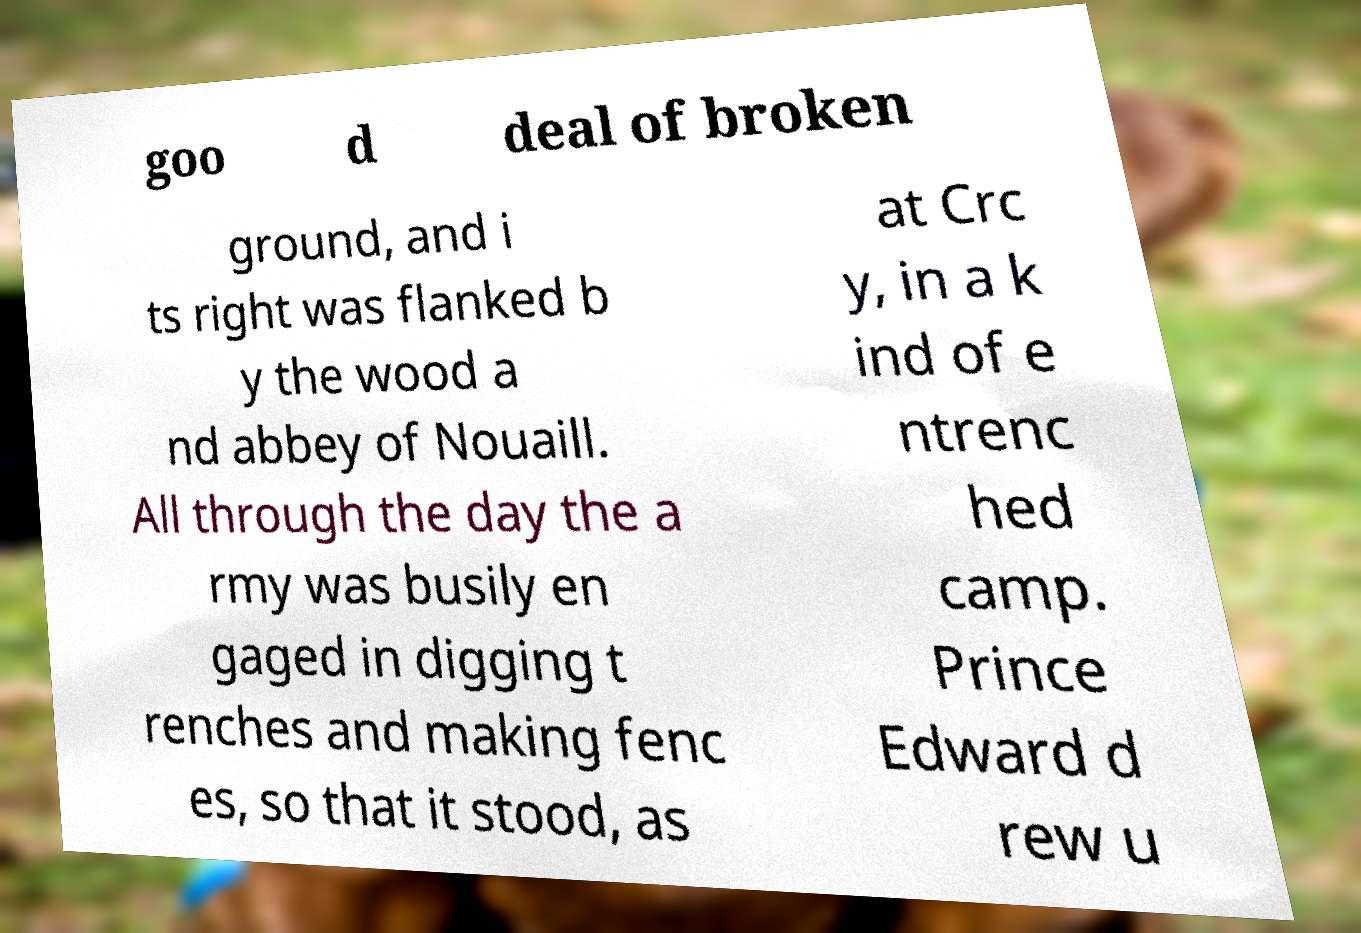Could you extract and type out the text from this image? goo d deal of broken ground, and i ts right was flanked b y the wood a nd abbey of Nouaill. All through the day the a rmy was busily en gaged in digging t renches and making fenc es, so that it stood, as at Crc y, in a k ind of e ntrenc hed camp. Prince Edward d rew u 